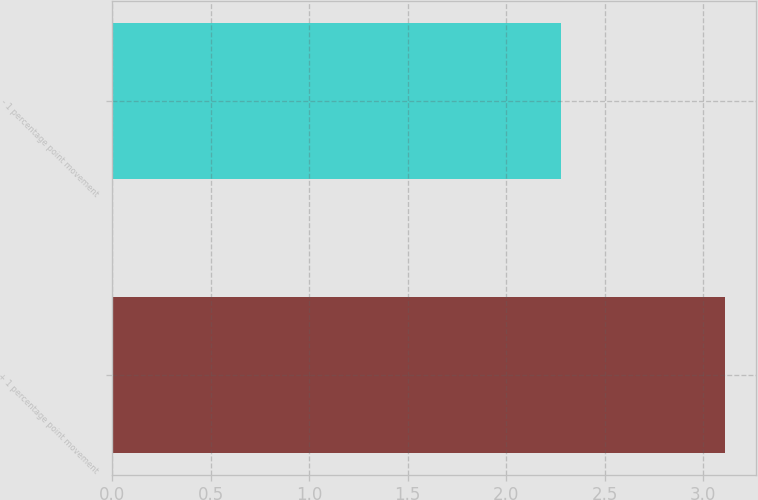Convert chart. <chart><loc_0><loc_0><loc_500><loc_500><bar_chart><fcel>+ 1 percentage point movement<fcel>- 1 percentage point movement<nl><fcel>3.11<fcel>2.28<nl></chart> 